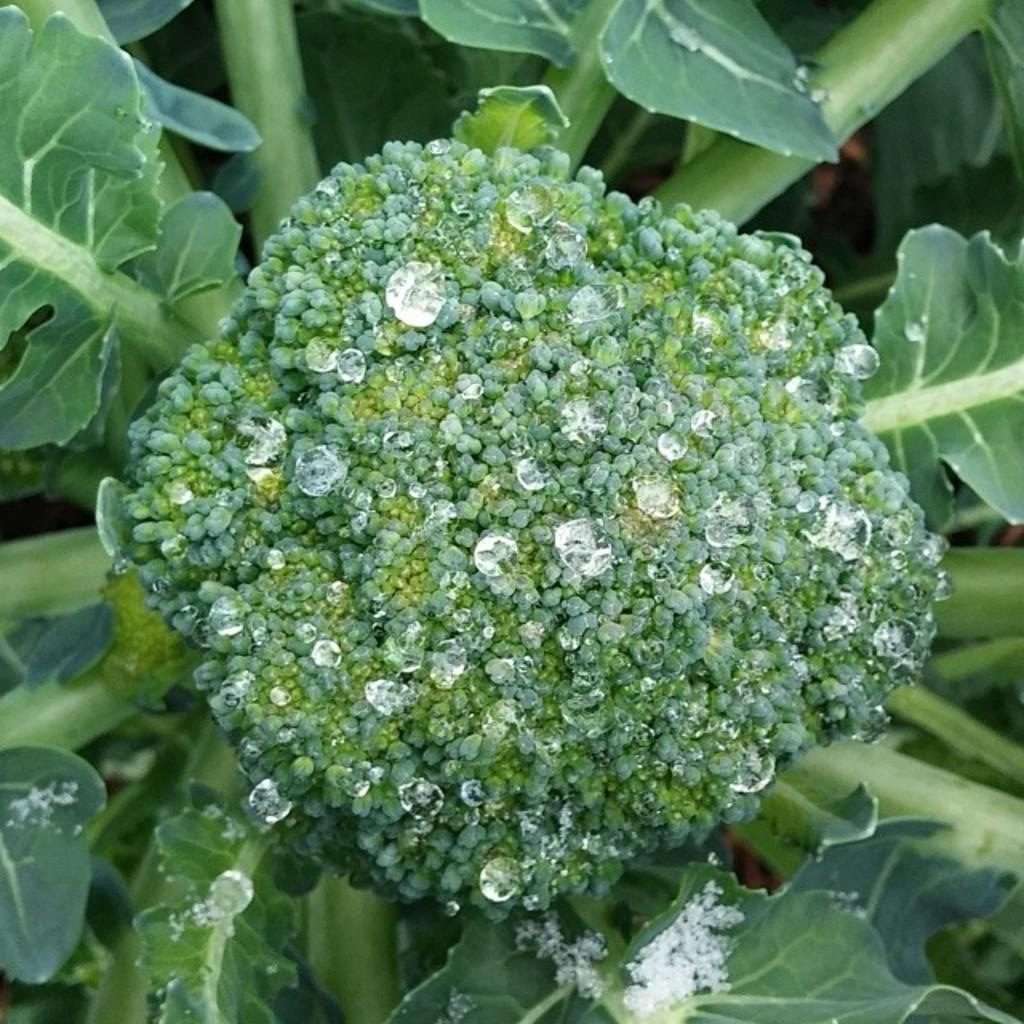What is the main subject of the image? The image appears to depict a cauliflower. What else can be seen in the image besides the cauliflower? There are leaves visible in the image. Are there any other notable features in the image? Yes, there are water droplets visible in the image. What type of joke is being told by the writer in the image? There is no writer or joke present in the image; it depicts a cauliflower with leaves and water droplets. 